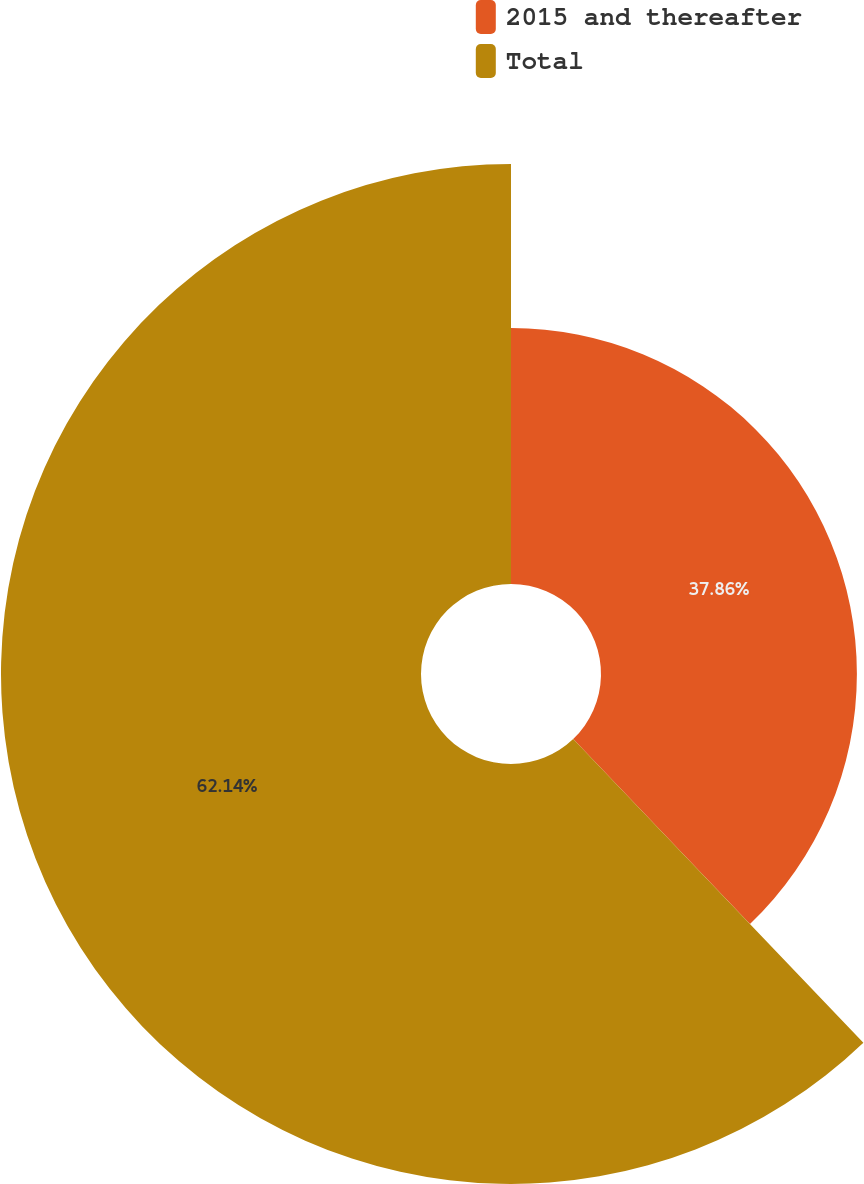<chart> <loc_0><loc_0><loc_500><loc_500><pie_chart><fcel>2015 and thereafter<fcel>Total<nl><fcel>37.86%<fcel>62.14%<nl></chart> 